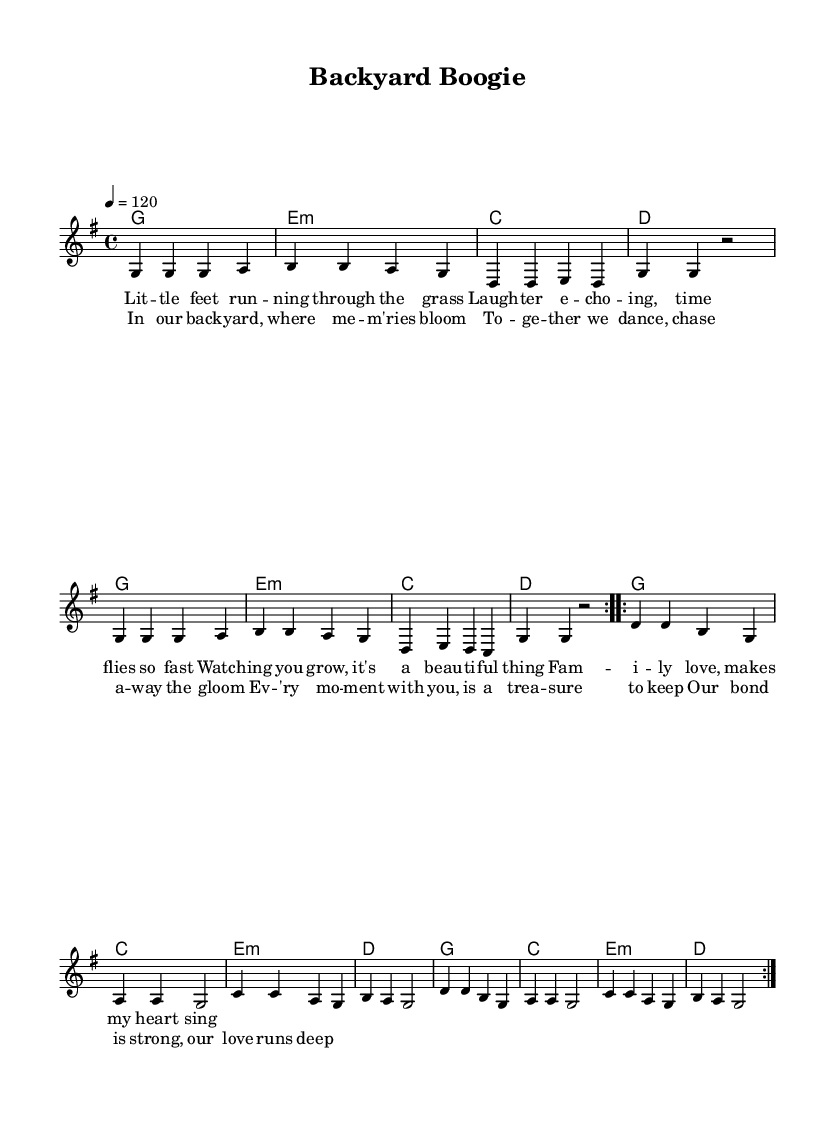What is the key signature of this music? The key signature is G major, which has one sharp (F#).
Answer: G major What is the time signature of this music? The time signature is 4/4, which means there are four beats in each measure.
Answer: 4/4 What is the tempo marking for this piece? The tempo marking states "4 = 120," indicating a moderate tempo of 120 beats per minute.
Answer: 120 How many measures are in the chorus? The chorus consists of 4 measures, as indicated by the repeated sections of the lyrics.
Answer: 4 What is the overall theme of the lyrics in this piece? The lyrics express family bonding and love, highlighting joyful moments and cherished memories together.
Answer: Family love What is the structure of the song? The song is structured into verses and a chorus, with repeated sections enhancing the upbeat feel characteristic of R&B.
Answer: Verse and chorus 